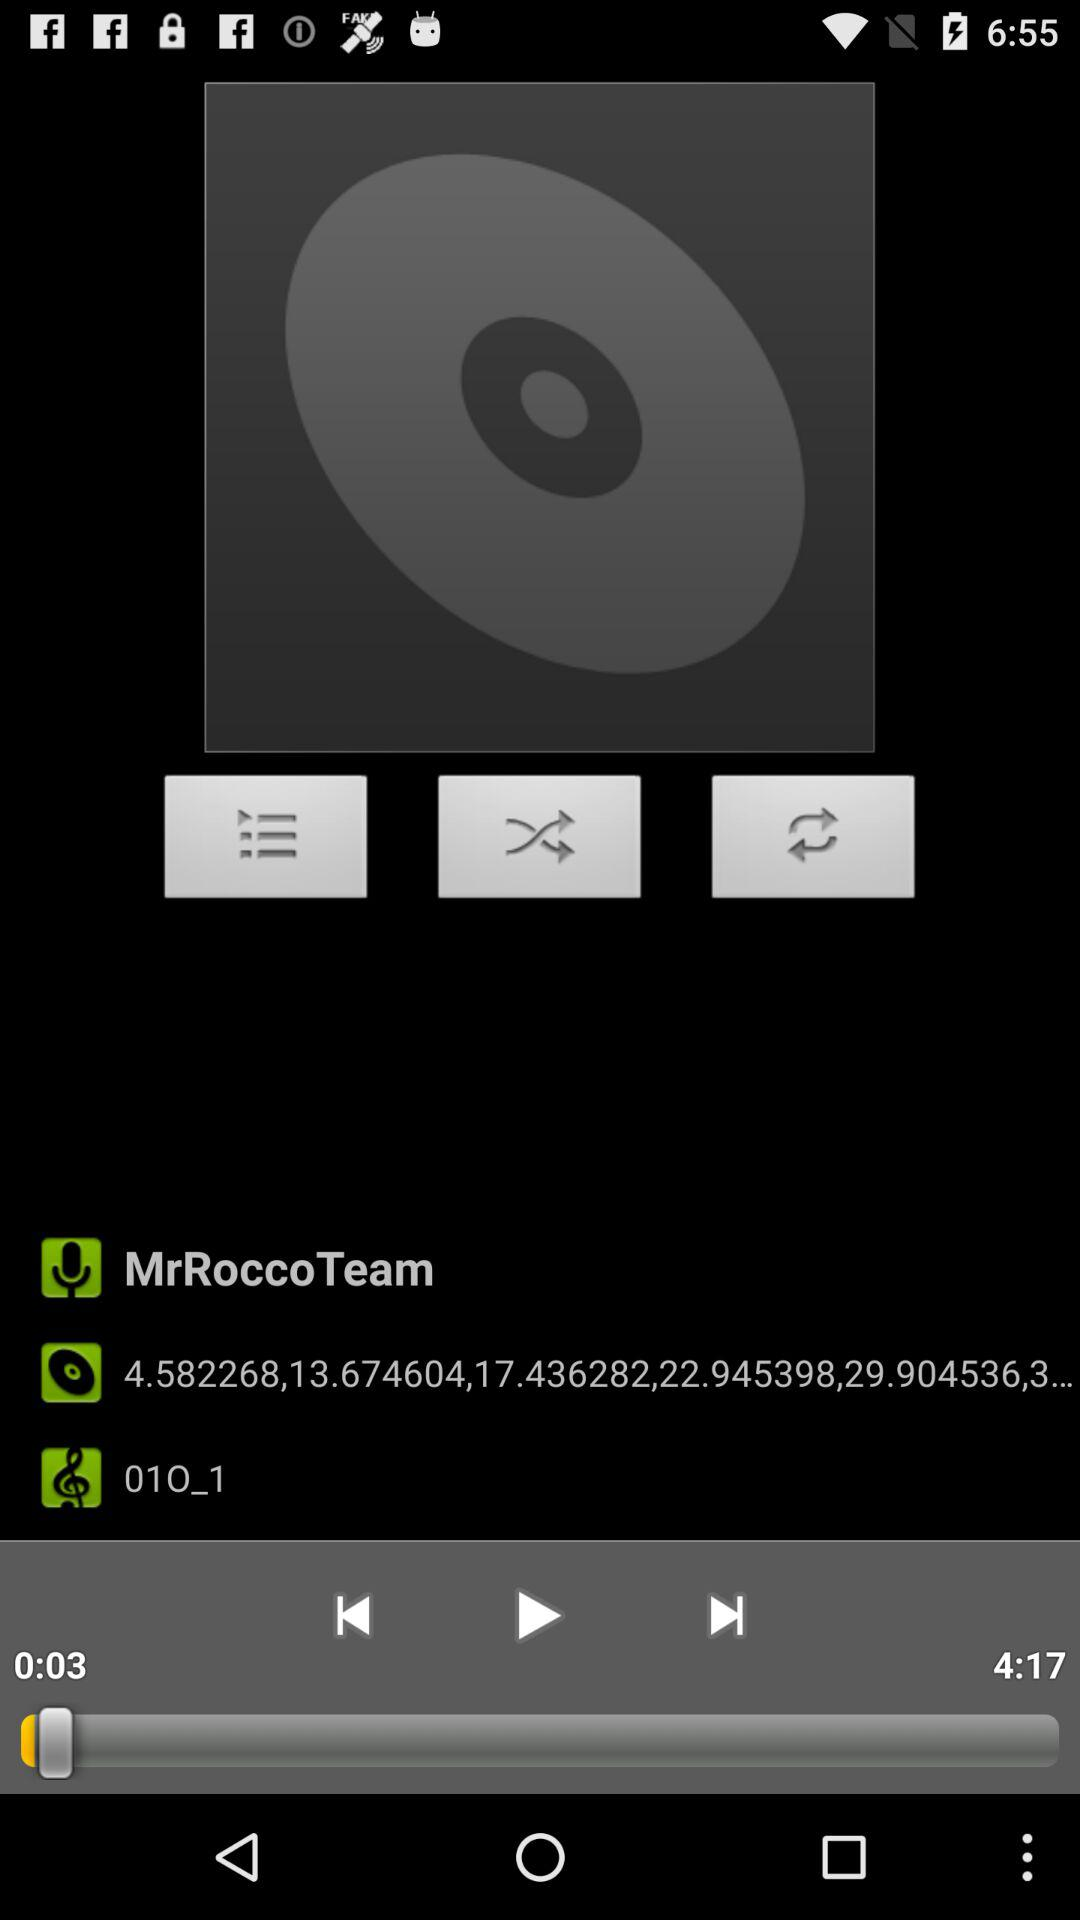For how long has the song been played? The song has been played for 3 seconds. 